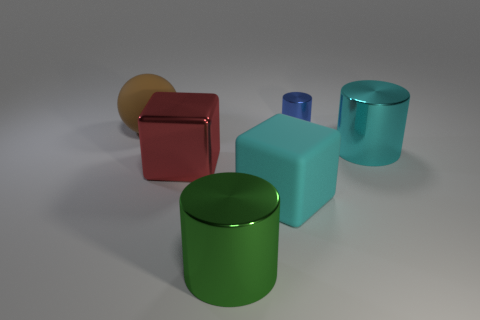There is a big cylinder to the right of the big cyan object left of the big shiny thing that is right of the green cylinder; what is it made of?
Your answer should be very brief. Metal. The matte sphere has what color?
Your answer should be compact. Brown. What number of small objects are either green things or matte things?
Keep it short and to the point. 0. What material is the object that is the same color as the rubber cube?
Offer a very short reply. Metal. Does the large cyan thing that is in front of the cyan metallic thing have the same material as the brown sphere in front of the blue metal cylinder?
Offer a terse response. Yes. Are any small blue shiny spheres visible?
Provide a succinct answer. No. Are there more big cubes that are right of the large brown thing than big rubber cubes behind the rubber block?
Your answer should be very brief. Yes. There is a cyan thing that is the same shape as the big green metal thing; what is it made of?
Make the answer very short. Metal. Is there any other thing that is the same size as the blue object?
Your answer should be very brief. No. There is a large rubber thing that is in front of the cyan metal cylinder; does it have the same color as the big shiny cylinder that is right of the cyan cube?
Provide a short and direct response. Yes. 